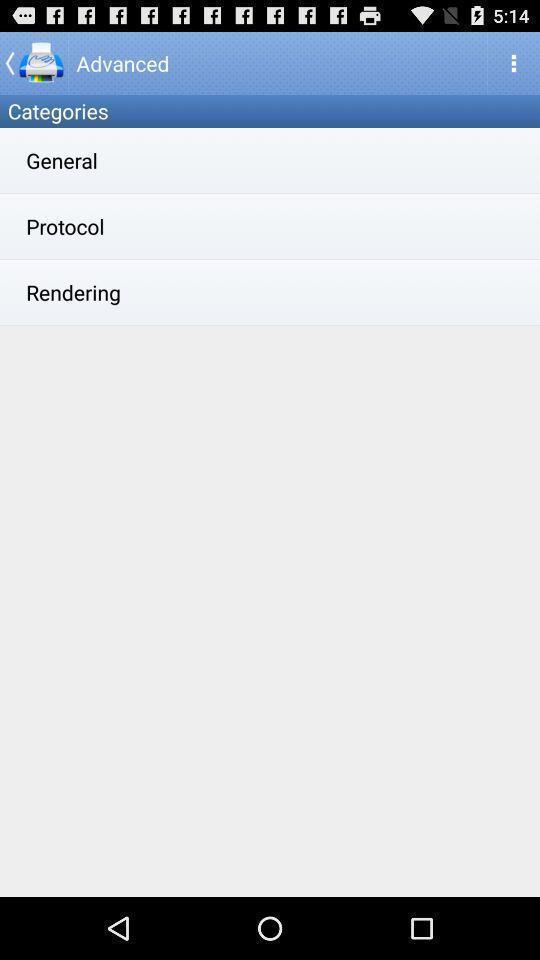Explain what's happening in this screen capture. Page displaying for printing app. 